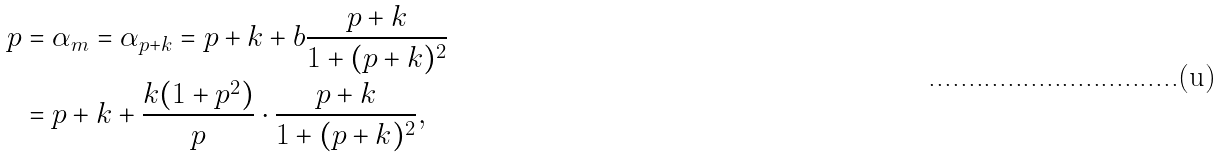<formula> <loc_0><loc_0><loc_500><loc_500>p & = \alpha _ { m } = \alpha _ { p + k } = p + k + b \frac { p + k } { 1 + ( p + k ) ^ { 2 } } \\ & = p + k + \frac { k ( 1 + p ^ { 2 } ) } { p } \cdot \frac { p + k } { 1 + ( p + k ) ^ { 2 } } ,</formula> 